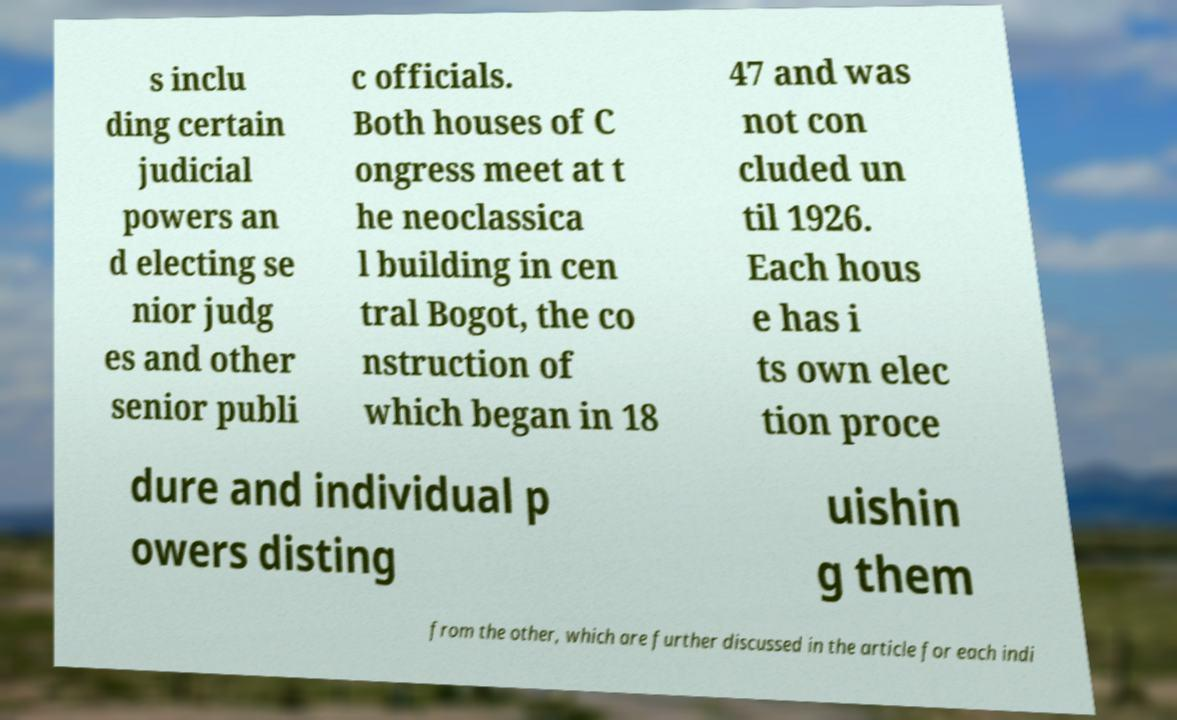For documentation purposes, I need the text within this image transcribed. Could you provide that? s inclu ding certain judicial powers an d electing se nior judg es and other senior publi c officials. Both houses of C ongress meet at t he neoclassica l building in cen tral Bogot, the co nstruction of which began in 18 47 and was not con cluded un til 1926. Each hous e has i ts own elec tion proce dure and individual p owers disting uishin g them from the other, which are further discussed in the article for each indi 